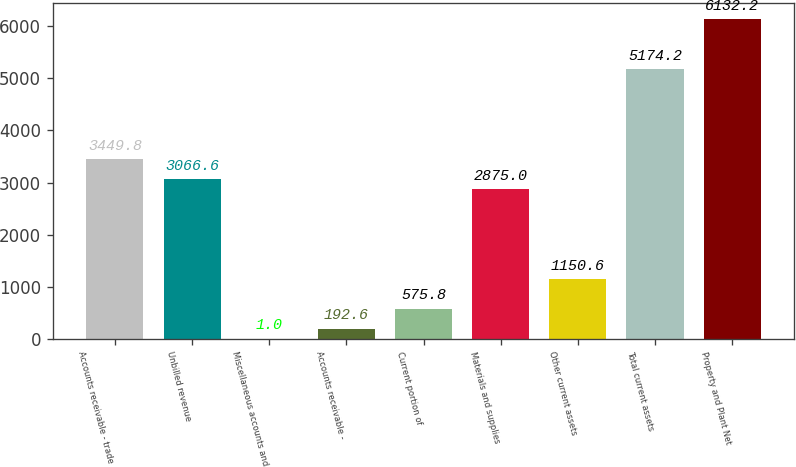<chart> <loc_0><loc_0><loc_500><loc_500><bar_chart><fcel>Accounts receivable - trade<fcel>Unbilled revenue<fcel>Miscellaneous accounts and<fcel>Accounts receivable -<fcel>Current portion of<fcel>Materials and supplies<fcel>Other current assets<fcel>Total current assets<fcel>Property and Plant Net<nl><fcel>3449.8<fcel>3066.6<fcel>1<fcel>192.6<fcel>575.8<fcel>2875<fcel>1150.6<fcel>5174.2<fcel>6132.2<nl></chart> 